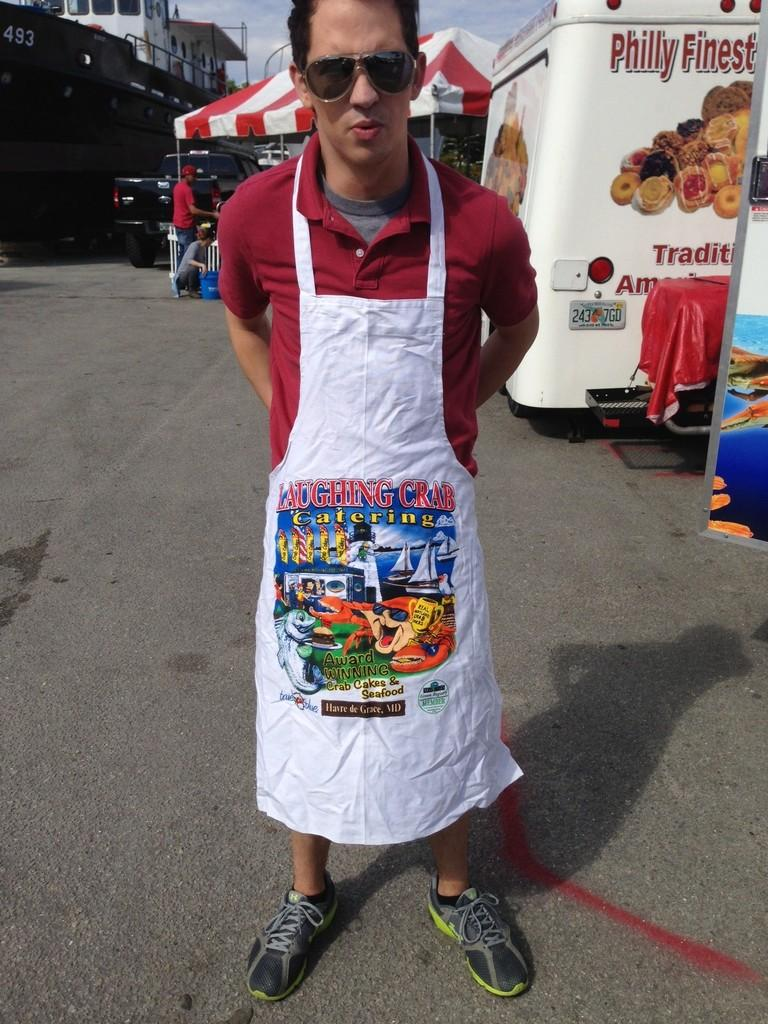<image>
Describe the image concisely. a man wearing an apron with the phrase laughing crab 